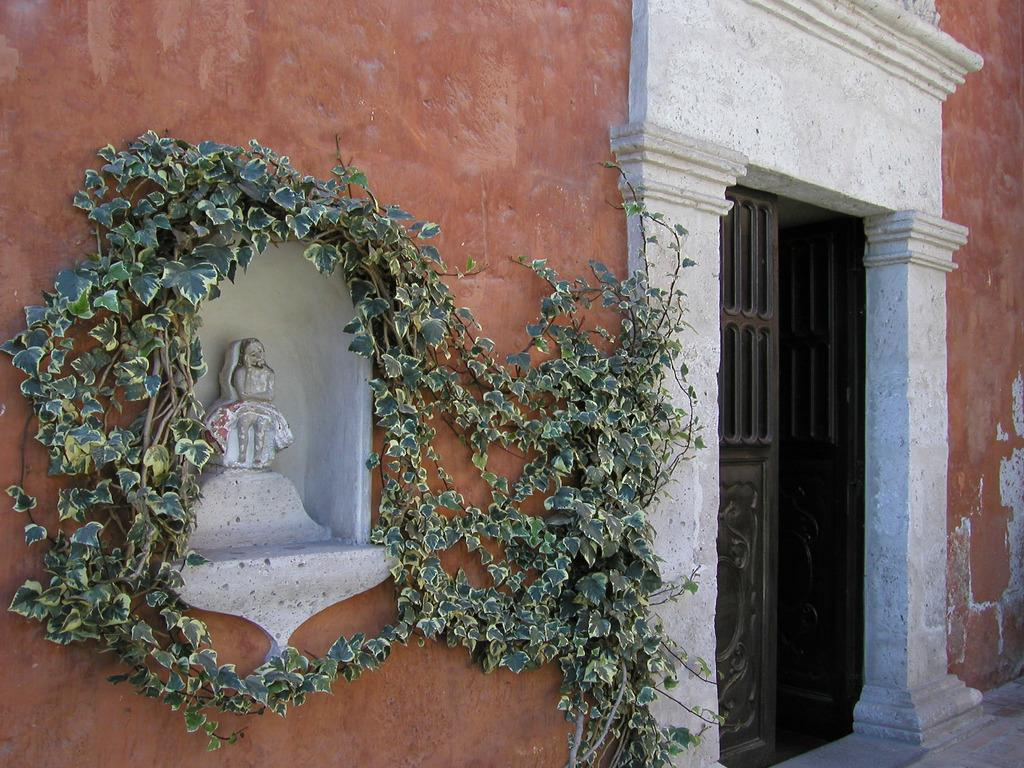What type of structure is in the image? There is a building in the image. What can be used to enter or exit the building? There are doors visible in the image. What type of artwork is present in the image? There is a sculpture in the image. What type of vegetation is present in the image? Creepers are present in the image. What language is being spoken by the wire in the image? There is no wire present in the image, and therefore no language being spoken. 